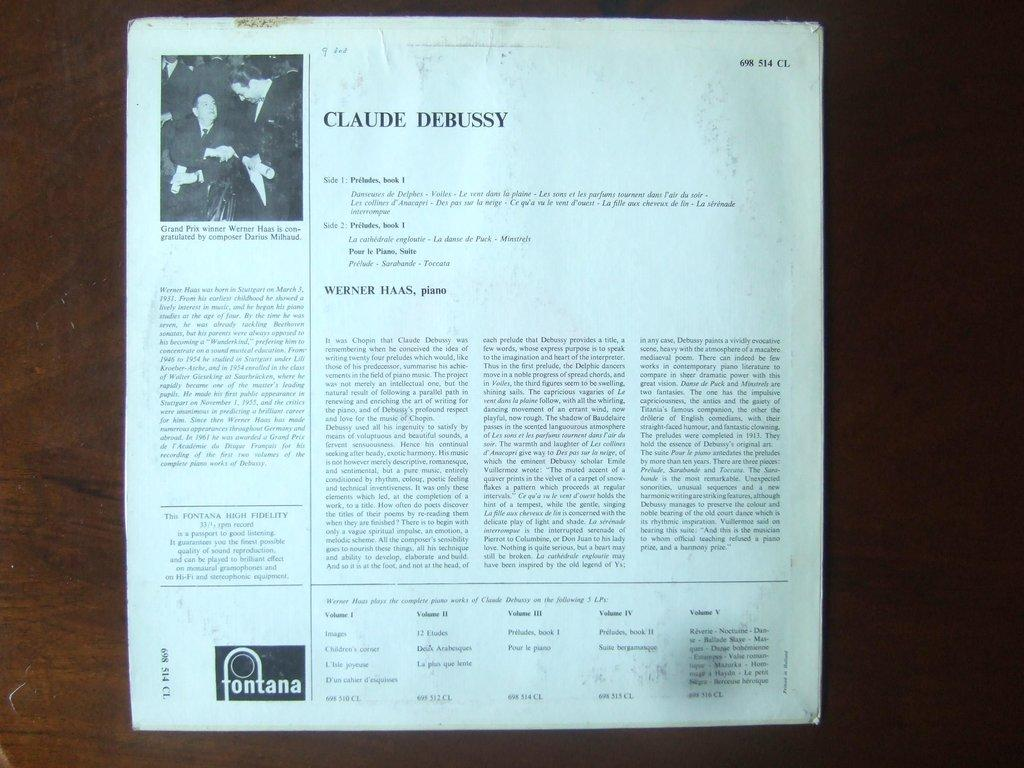<image>
Provide a brief description of the given image. A text sheet of paper with and image of two men titled Claude Debussy. 